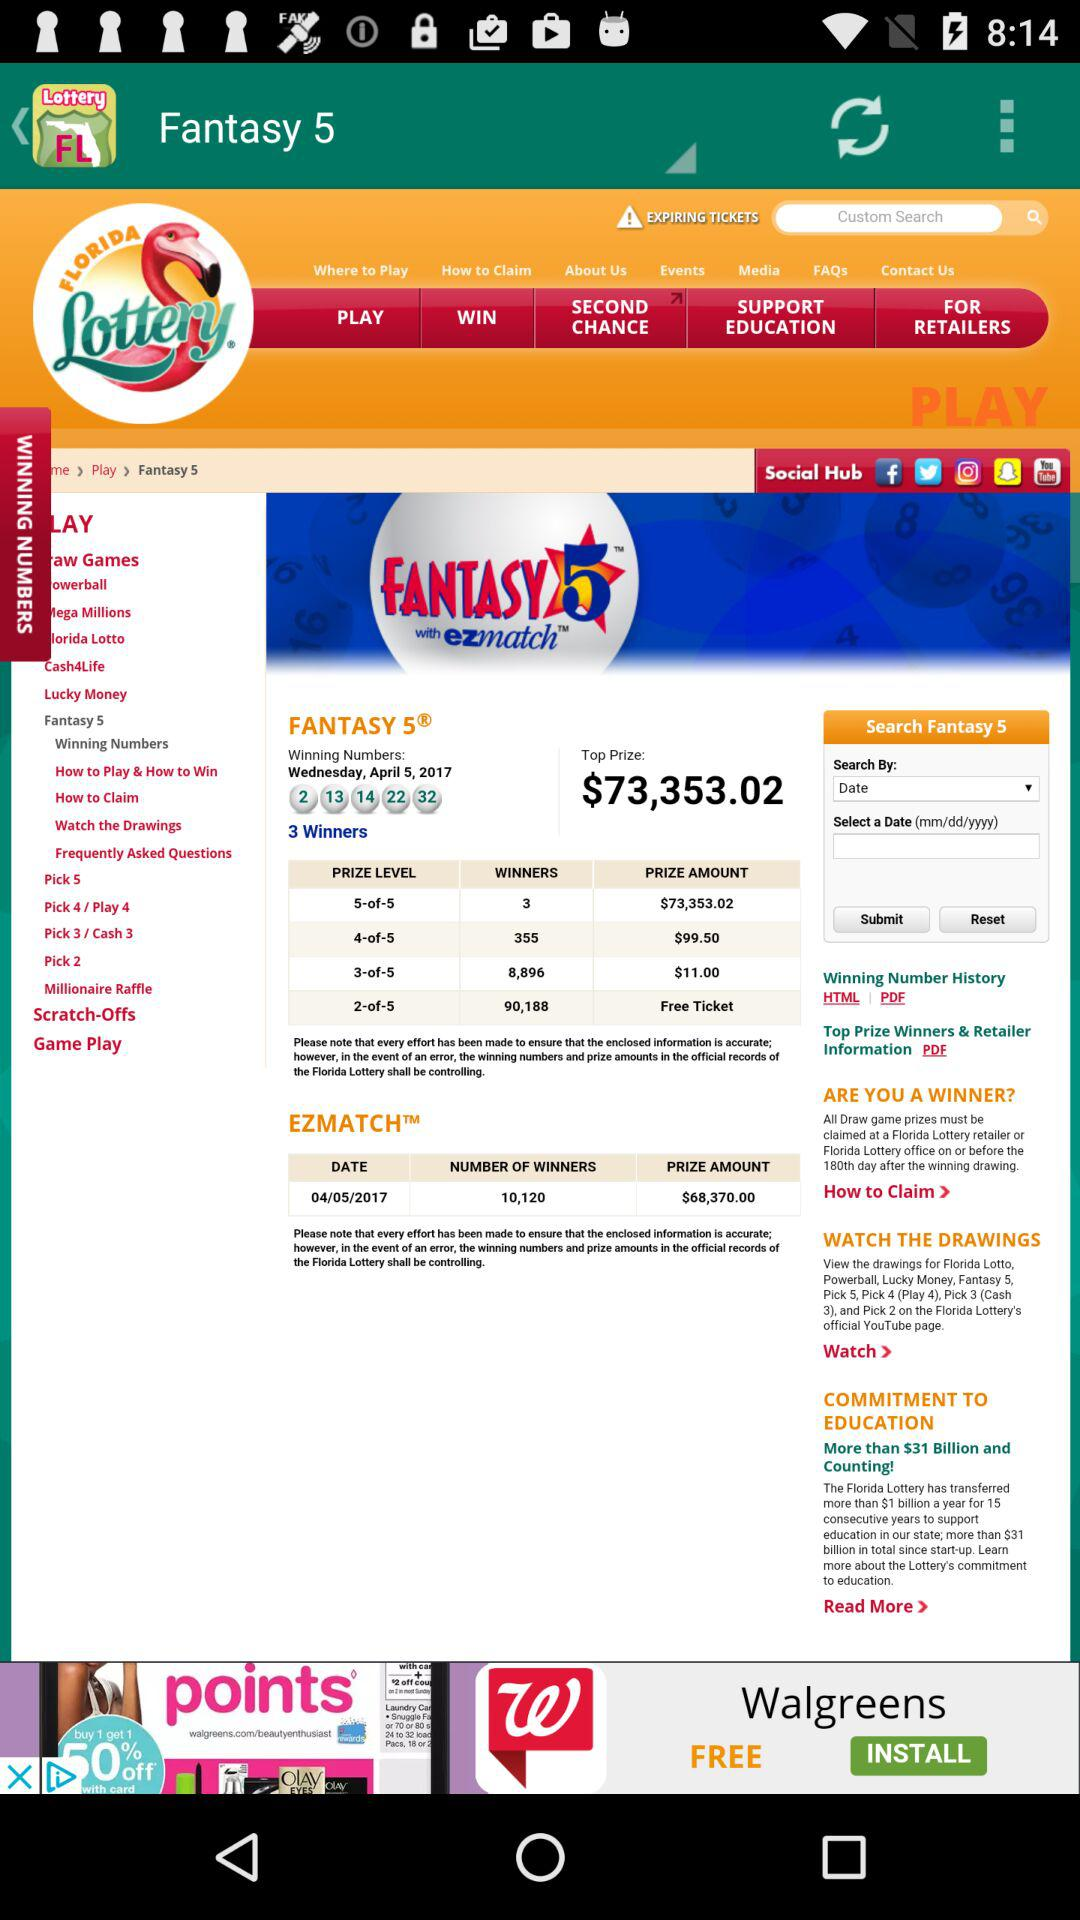How many people win at the 3-of-5 level? There are 8,896 winners at the 3-of-5 level. 